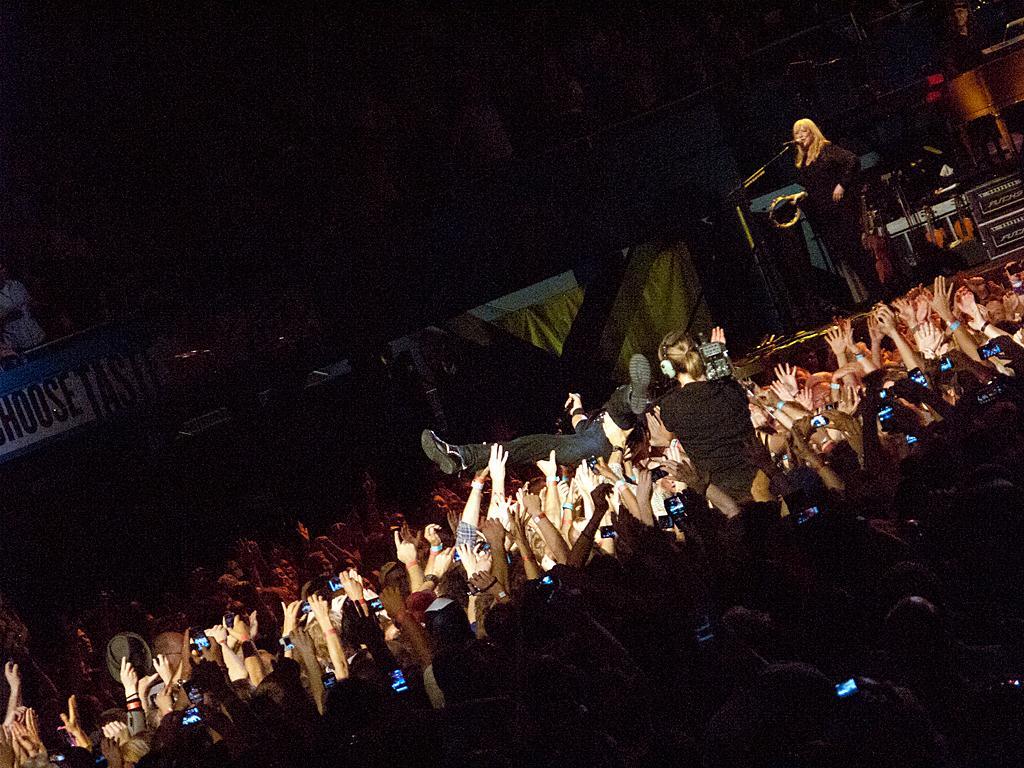Describe this image in one or two sentences. In this image we can see many people. There is a lady standing. In front of her there is a mic with mic stand. In the back there is a board with text. In the background it is dark. And we can see a person holding a video camera and wearing headphone. 